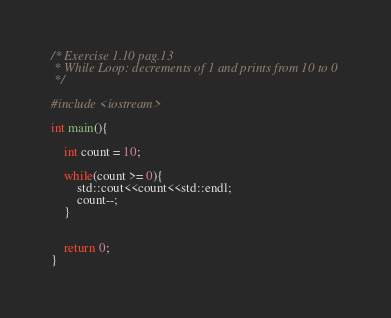<code> <loc_0><loc_0><loc_500><loc_500><_C++_>/* Exercise 1.10 pag.13
 * While Loop: decrements of 1 and prints from 10 to 0
 */

#include <iostream>

int main(){

	int count = 10;

	while(count >= 0){
		std::cout<<count<<std::endl;
		count--;
	}


	return 0;
}</code> 